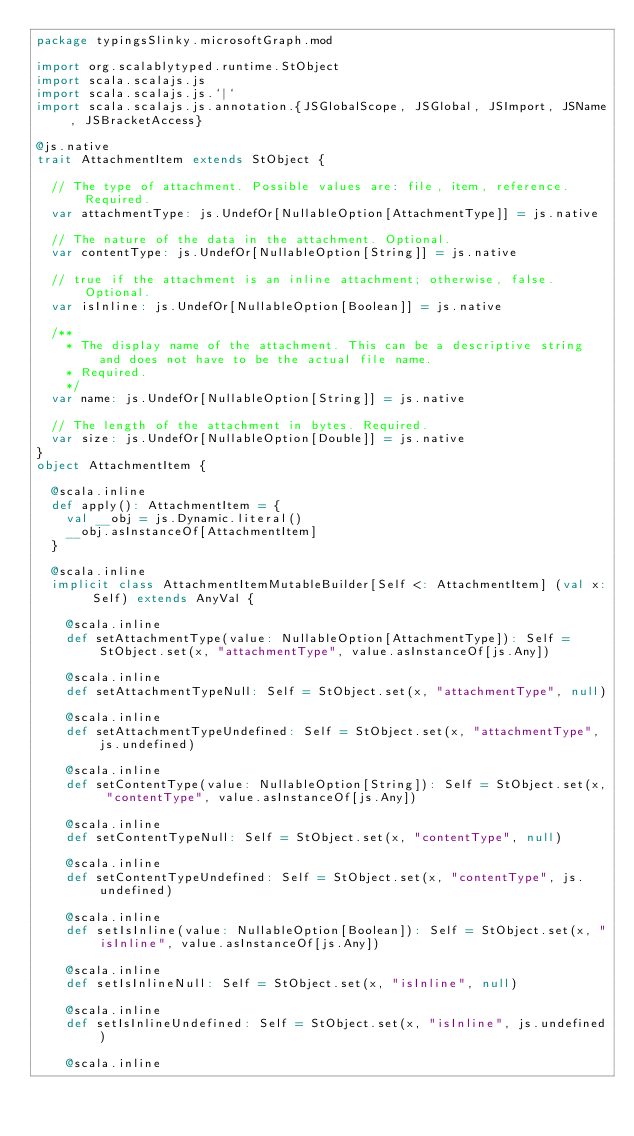Convert code to text. <code><loc_0><loc_0><loc_500><loc_500><_Scala_>package typingsSlinky.microsoftGraph.mod

import org.scalablytyped.runtime.StObject
import scala.scalajs.js
import scala.scalajs.js.`|`
import scala.scalajs.js.annotation.{JSGlobalScope, JSGlobal, JSImport, JSName, JSBracketAccess}

@js.native
trait AttachmentItem extends StObject {
  
  // The type of attachment. Possible values are: file, item, reference. Required.
  var attachmentType: js.UndefOr[NullableOption[AttachmentType]] = js.native
  
  // The nature of the data in the attachment. Optional.
  var contentType: js.UndefOr[NullableOption[String]] = js.native
  
  // true if the attachment is an inline attachment; otherwise, false. Optional.
  var isInline: js.UndefOr[NullableOption[Boolean]] = js.native
  
  /**
    * The display name of the attachment. This can be a descriptive string and does not have to be the actual file name.
    * Required.
    */
  var name: js.UndefOr[NullableOption[String]] = js.native
  
  // The length of the attachment in bytes. Required.
  var size: js.UndefOr[NullableOption[Double]] = js.native
}
object AttachmentItem {
  
  @scala.inline
  def apply(): AttachmentItem = {
    val __obj = js.Dynamic.literal()
    __obj.asInstanceOf[AttachmentItem]
  }
  
  @scala.inline
  implicit class AttachmentItemMutableBuilder[Self <: AttachmentItem] (val x: Self) extends AnyVal {
    
    @scala.inline
    def setAttachmentType(value: NullableOption[AttachmentType]): Self = StObject.set(x, "attachmentType", value.asInstanceOf[js.Any])
    
    @scala.inline
    def setAttachmentTypeNull: Self = StObject.set(x, "attachmentType", null)
    
    @scala.inline
    def setAttachmentTypeUndefined: Self = StObject.set(x, "attachmentType", js.undefined)
    
    @scala.inline
    def setContentType(value: NullableOption[String]): Self = StObject.set(x, "contentType", value.asInstanceOf[js.Any])
    
    @scala.inline
    def setContentTypeNull: Self = StObject.set(x, "contentType", null)
    
    @scala.inline
    def setContentTypeUndefined: Self = StObject.set(x, "contentType", js.undefined)
    
    @scala.inline
    def setIsInline(value: NullableOption[Boolean]): Self = StObject.set(x, "isInline", value.asInstanceOf[js.Any])
    
    @scala.inline
    def setIsInlineNull: Self = StObject.set(x, "isInline", null)
    
    @scala.inline
    def setIsInlineUndefined: Self = StObject.set(x, "isInline", js.undefined)
    
    @scala.inline</code> 